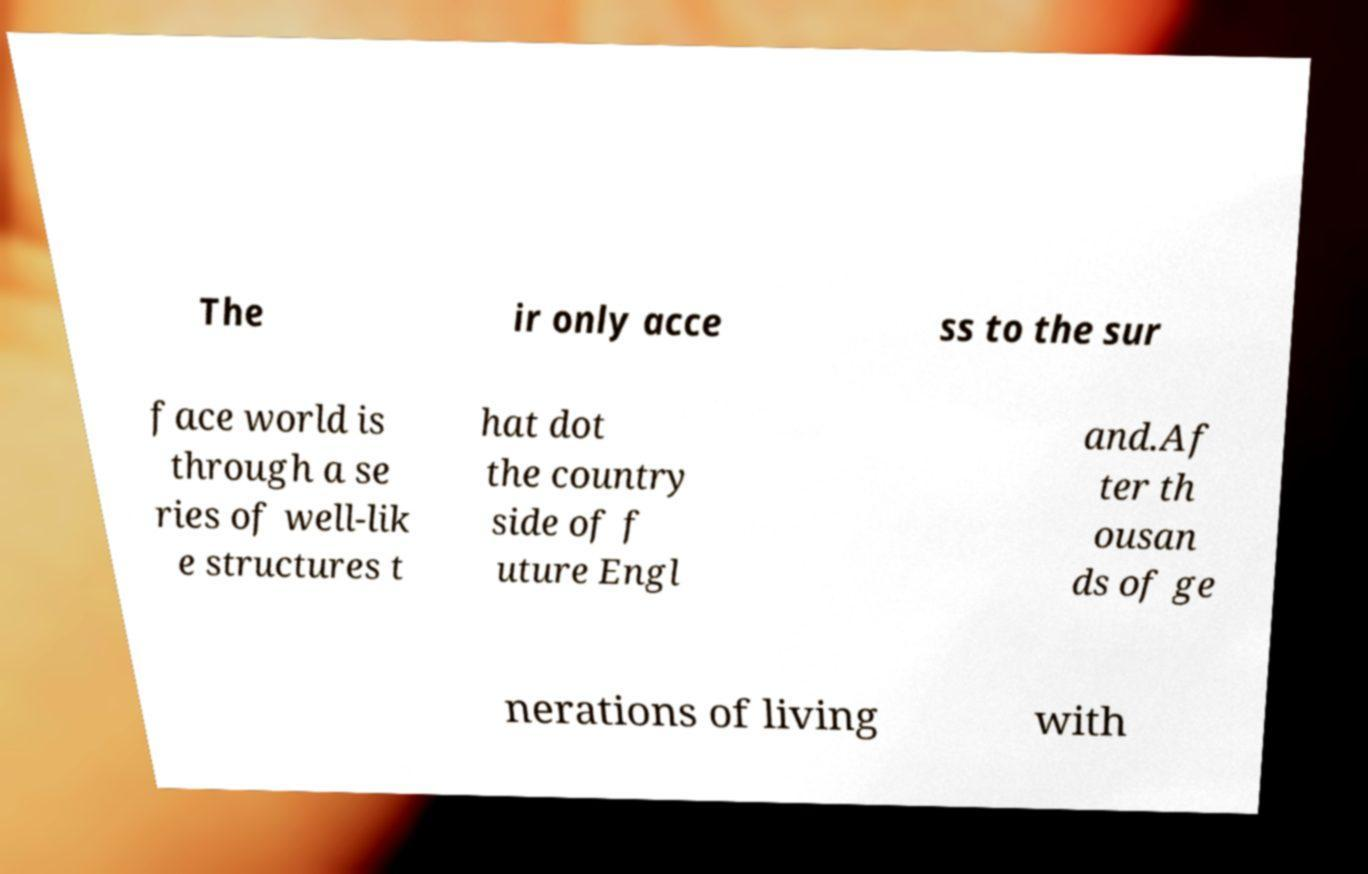Please read and relay the text visible in this image. What does it say? The ir only acce ss to the sur face world is through a se ries of well-lik e structures t hat dot the country side of f uture Engl and.Af ter th ousan ds of ge nerations of living with 